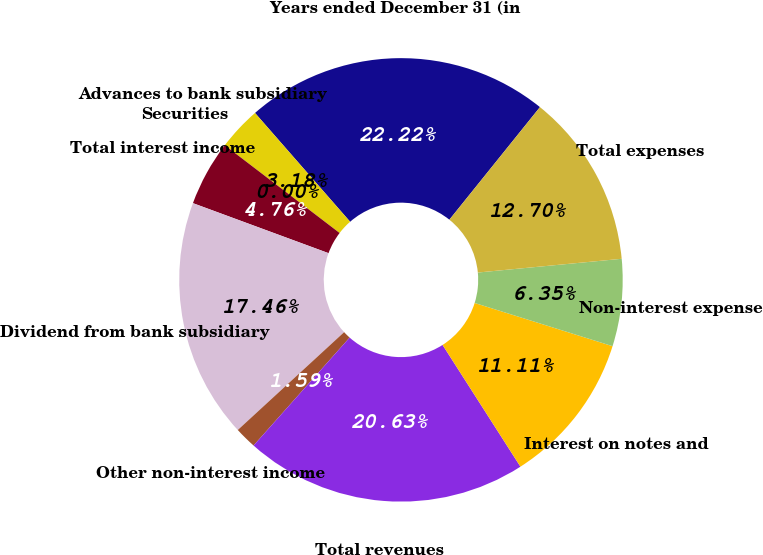Convert chart. <chart><loc_0><loc_0><loc_500><loc_500><pie_chart><fcel>Years ended December 31 (in<fcel>Advances to bank subsidiary<fcel>Securities<fcel>Total interest income<fcel>Dividend from bank subsidiary<fcel>Other non-interest income<fcel>Total revenues<fcel>Interest on notes and<fcel>Non-interest expense<fcel>Total expenses<nl><fcel>22.22%<fcel>3.18%<fcel>0.0%<fcel>4.76%<fcel>17.46%<fcel>1.59%<fcel>20.63%<fcel>11.11%<fcel>6.35%<fcel>12.7%<nl></chart> 